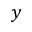<formula> <loc_0><loc_0><loc_500><loc_500>y</formula> 